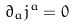<formula> <loc_0><loc_0><loc_500><loc_500>\partial _ { a } j ^ { a } = 0</formula> 